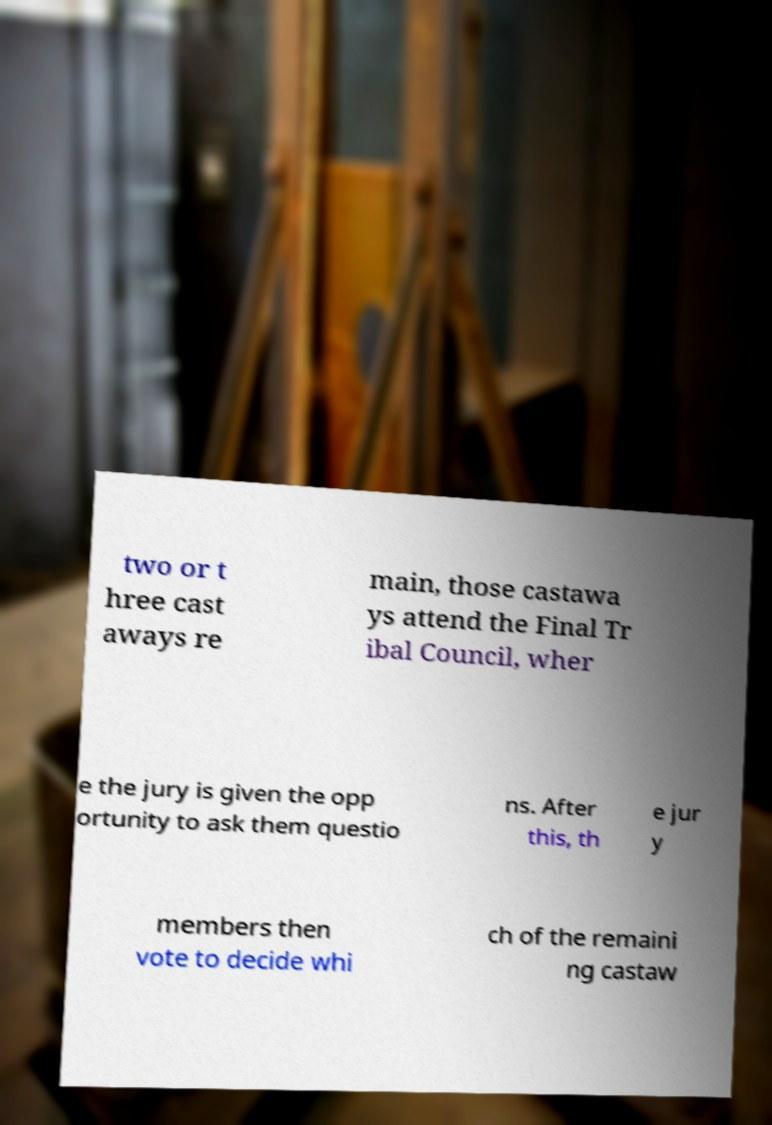Can you accurately transcribe the text from the provided image for me? two or t hree cast aways re main, those castawa ys attend the Final Tr ibal Council, wher e the jury is given the opp ortunity to ask them questio ns. After this, th e jur y members then vote to decide whi ch of the remaini ng castaw 